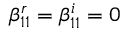Convert formula to latex. <formula><loc_0><loc_0><loc_500><loc_500>\beta _ { 1 1 } ^ { r } = \beta _ { 1 1 } ^ { i } = 0</formula> 